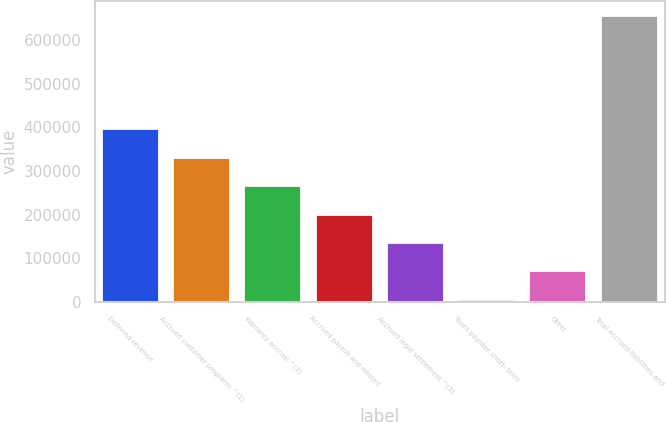Convert chart to OTSL. <chart><loc_0><loc_0><loc_500><loc_500><bar_chart><fcel>Deferred revenue<fcel>Accrued customer programs ^(1)<fcel>Warranty accrual ^(2)<fcel>Accrued payroll and related<fcel>Accrued legal settlement ^(3)<fcel>Taxes payable short- term<fcel>Other<fcel>Total accrued liabilities and<nl><fcel>395757<fcel>330560<fcel>265363<fcel>200166<fcel>134970<fcel>4576<fcel>69772.8<fcel>656544<nl></chart> 